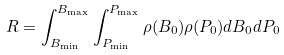Convert formula to latex. <formula><loc_0><loc_0><loc_500><loc_500>R = \int _ { B _ { \min } } ^ { B _ { \max } } \int _ { P _ { \min } } ^ { P _ { \max } } \rho ( B _ { 0 } ) \rho ( P _ { 0 } ) d B _ { 0 } d P _ { 0 }</formula> 